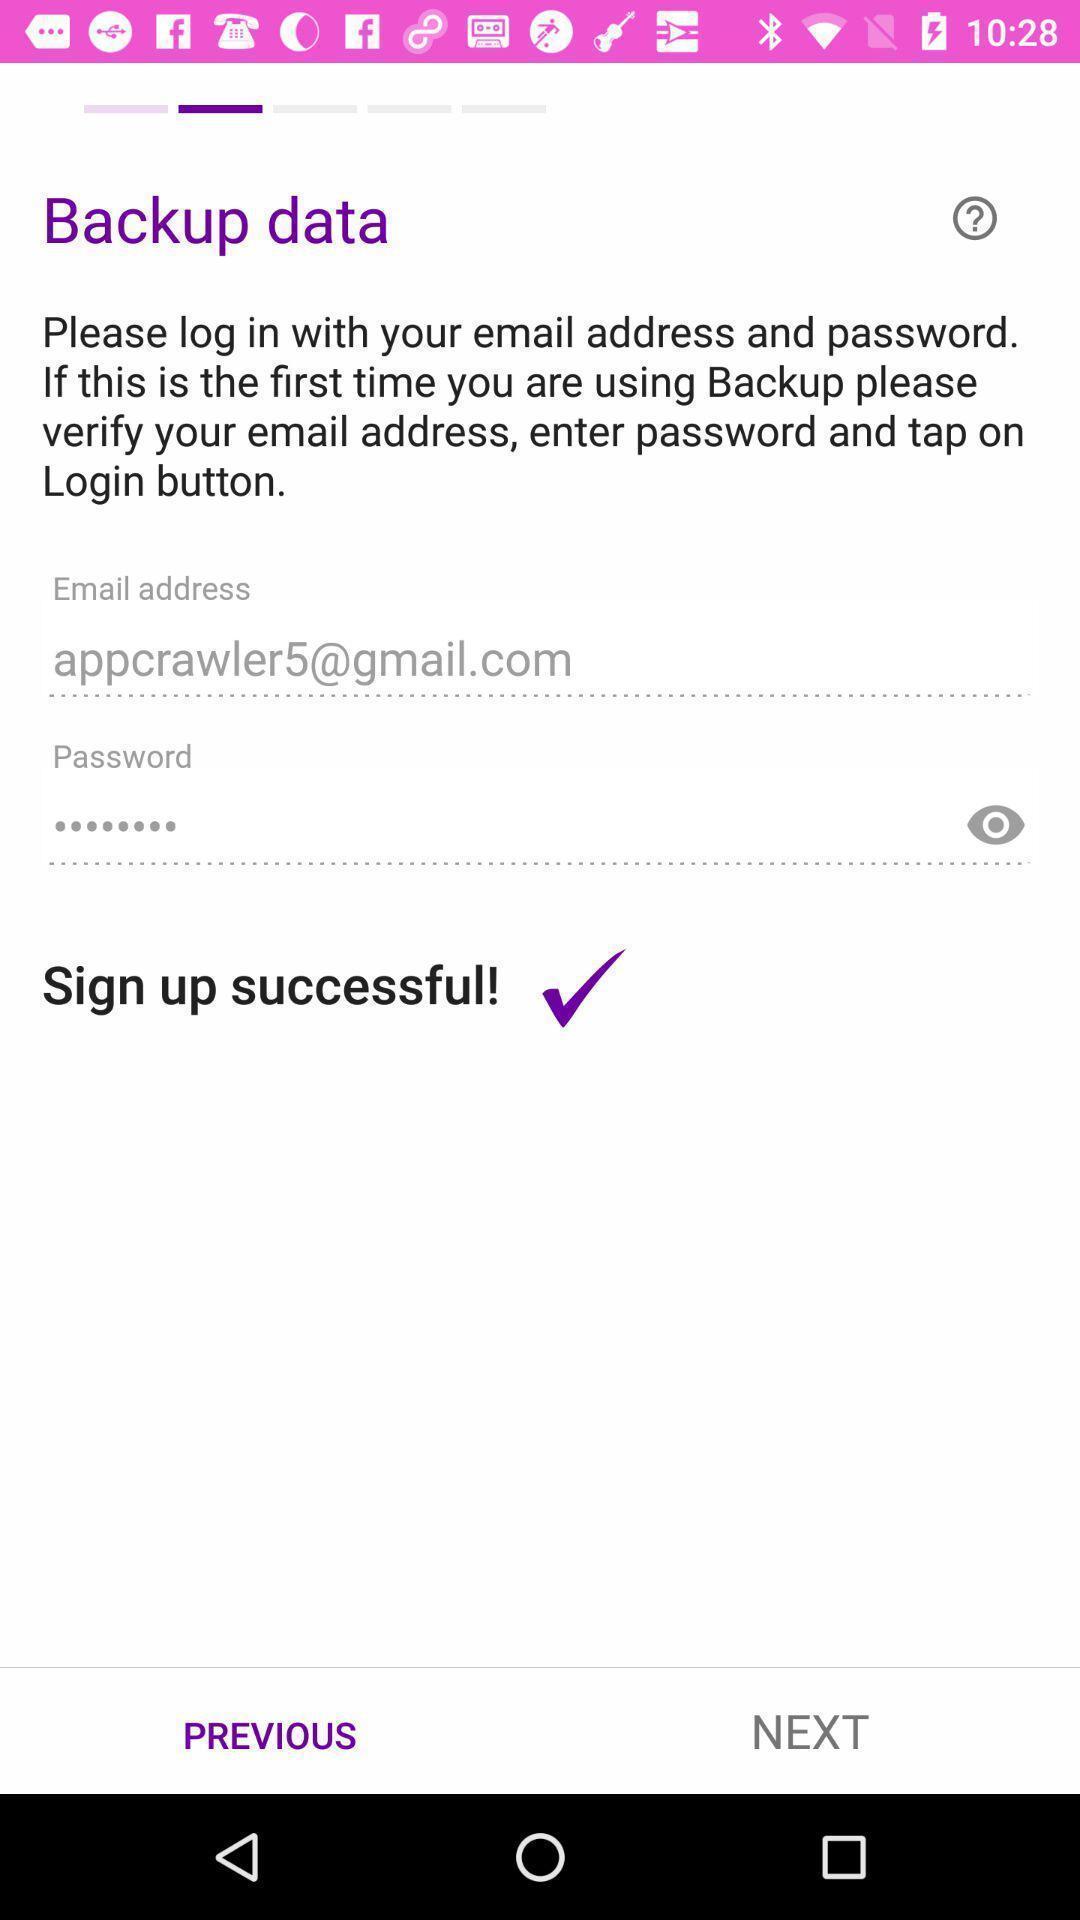Give me a narrative description of this picture. Screen displaying signing up of an account to backup data. 